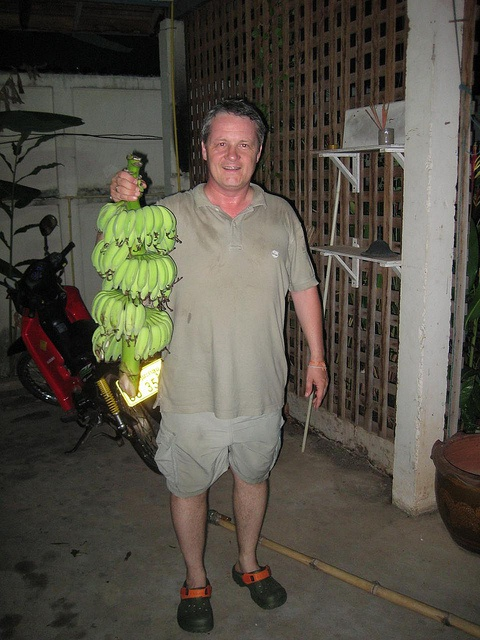Describe the objects in this image and their specific colors. I can see people in black, darkgray, and gray tones, motorcycle in black, maroon, gray, and olive tones, and banana in black, olive, lightgreen, and darkgreen tones in this image. 